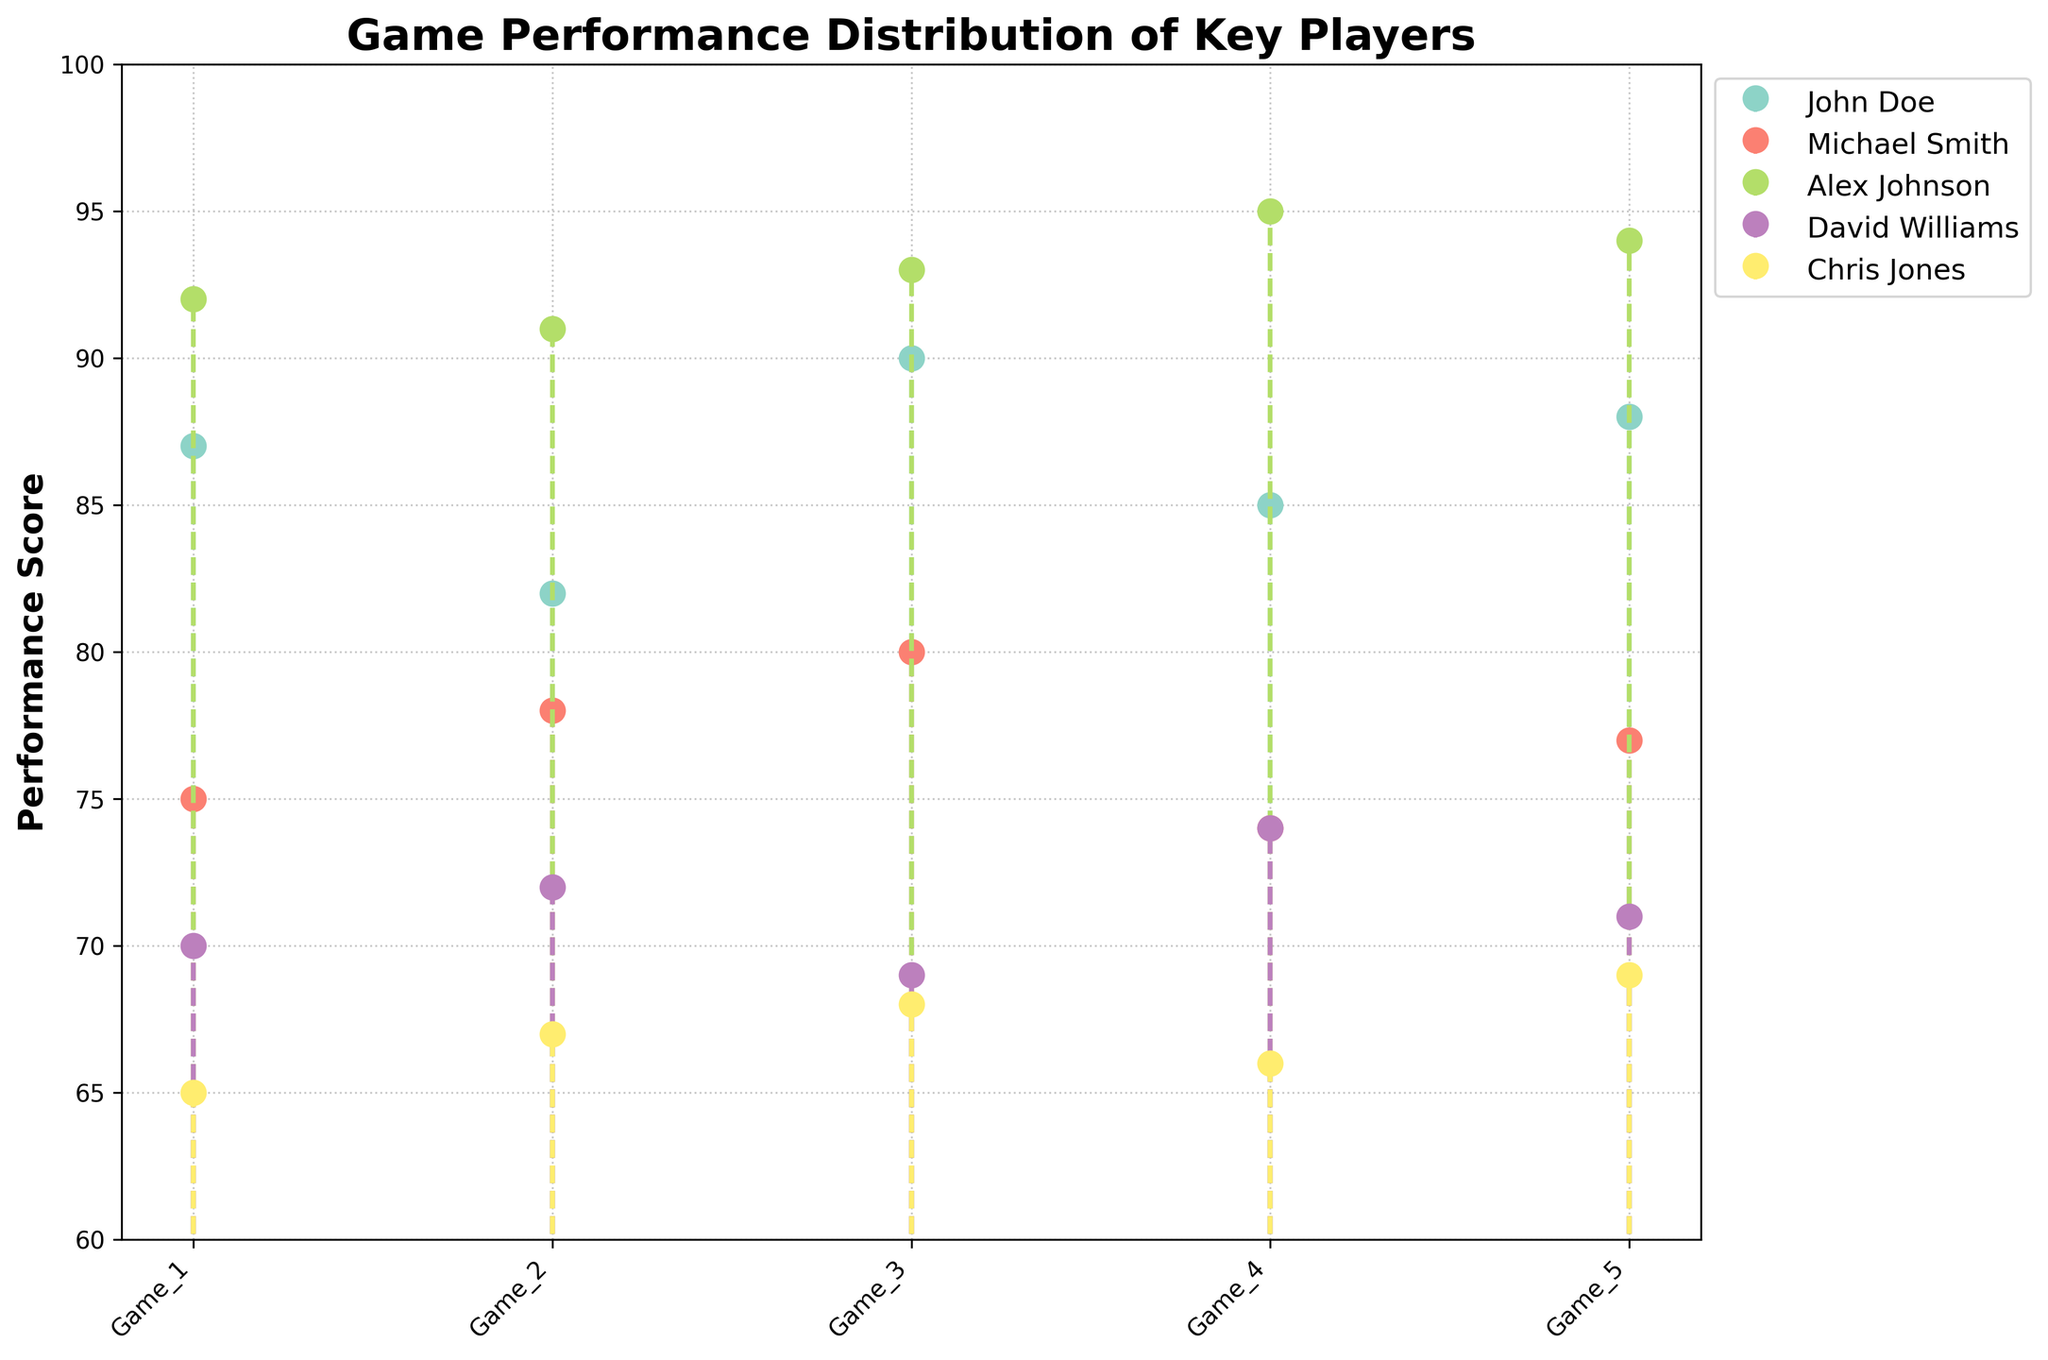what is the title of the plot? The title is usually located at the top of the figure, providing a summary of what the plot is about. Here, it indicates the context and subject of the plot.
Answer: Game Performance Distribution of Key Players What is the performance score range on the y-axis? The y-axis defines the range of the performance scores depicted in the plot. Examining the y-axis, the scale ranges from 60 to 100.
Answer: 60 to 100 How many players are represented in the plot? By looking at the legend, which displays the names of all the key players depicted in the plot, we can count the total number of players.
Answer: 5 Which player has the highest single-game performance score? By comparing all the stem heights across the games, we can identify the highest individual score. Alex Johnson's stem in Game 4, which corresponds to 95, is the tallest.
Answer: Alex Johnson What is the average performance score for Michael Smith across the 5 games? Sum Michael Smith's scores (75, 78, 80, 74, 77) and divide by 5. The calculation is (75 + 78 + 80 + 74 + 77) / 5 = 76.8.
Answer: 76.8 Who has the most consistent performance across the games, indicated by the least variation in stem heights? Consistency can be judged by the uniformity of the stem heights for each player. Alex Johnson's stems are the most uniform, only varying slightly around 93.
Answer: Alex Johnson Which game did Chris Jones perform the worst in? By checking the heights of Chris Jones' stems across games, we find the shortest stem represents the lowest score. His lowest performance is in Game 1 with a score of 65.
Answer: Game 1 Does David Williams's performance improve, decline, or stay consistent over the 5 games? Observing the trend of the stem heights for David Williams across all games shows no clear upward or downward movement, indicating a fairly consistent performance.
Answer: Consistent How many players have at least one game with a performance score above 90? Checking each player's stems, only Alex Johnson shows performance scores above 90 in all his games.
Answer: 1 Compare the performance of John Doe in Game 3 to David Williams in the same game. Who performed better? Looking at the stem heights for both players in Game 3, John Doe scores 90, whereas David Williams scores 69. Hence, John Doe performed better.
Answer: John Doe 